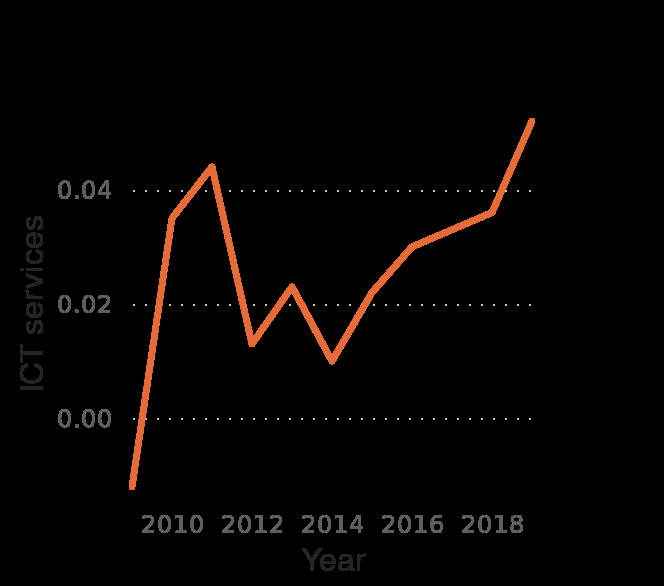<image>
When did the ICT sector experience rapid growth?  The ICT sector experienced rapid growth between 2010 and 2012. 